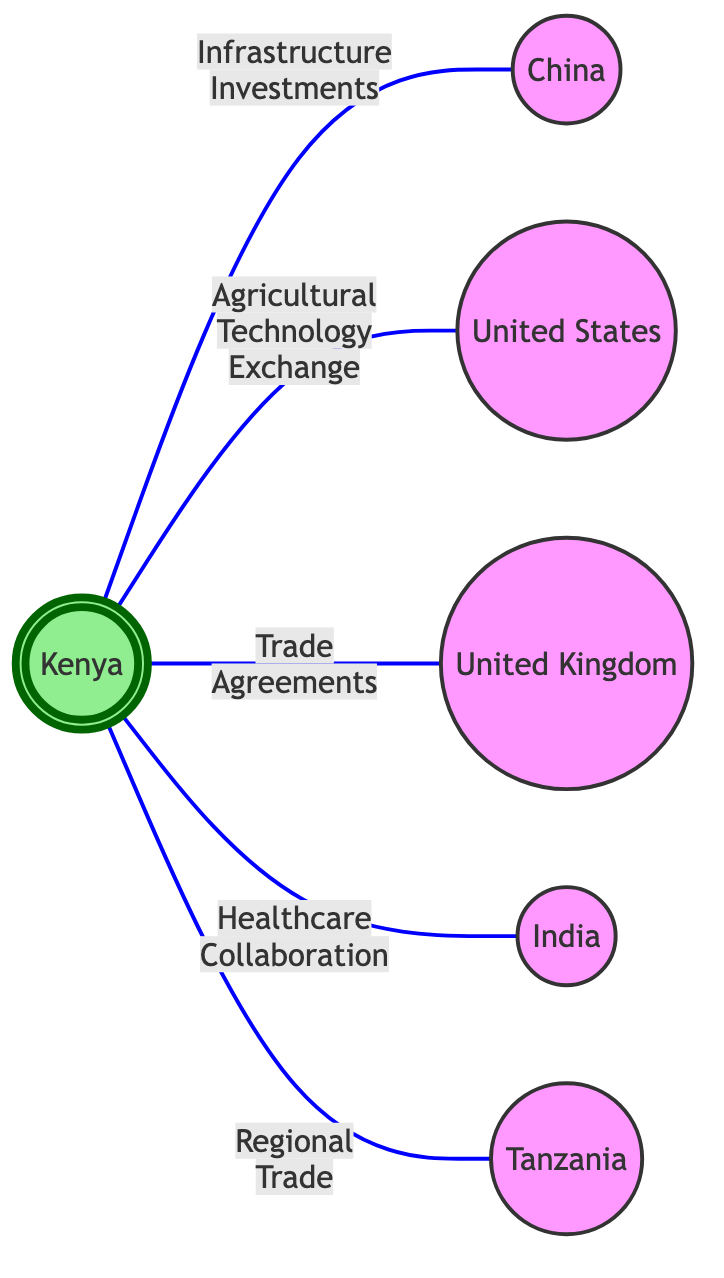What is the total number of countries represented in the diagram? The diagram includes six distinct nodes representing countries: Kenya, China, United States, United Kingdom, India, and Tanzania. Counting these gives a total of 6 countries.
Answer: 6 What type of collaboration exists between Kenya and China? The diagram shows an edge labeled "Infrastructure Investments" connecting Kenya and China, indicating the specific type of collaboration between these two countries.
Answer: Infrastructure Investments How many collaborations are shown between Kenya and other countries? There are five edges emerging from Kenya, each representing a different collaboration with the mentioned countries. Thus, there are 5 collaborations in total.
Answer: 5 Which country is connected to Kenya through healthcare collaboration? The diagram indicates an edge labeled "Healthcare Collaboration" connecting Kenya to India, identifying India as the country engaged in this type of collaboration with Kenya.
Answer: India Which two countries have a trade agreement with Kenya? The edges labeled "Trade Agreements" connect Kenya to the United Kingdom. Therefore, the United Kingdom is the only country shown in this diagram with a trade agreement with Kenya.
Answer: United Kingdom Which type of collaboration exists between Kenya and the United States? The diagram illustrates that there is an edge labeled "Agricultural Technology Exchange" between Kenya and the United States, clarifying the nature of their collaboration.
Answer: Agricultural Technology Exchange How many edges are connected to Kenya in the graph? Upon examining the diagram, there are five edges originating from Kenya, which connect to each of the other countries represented. This confirms that Kenya has 5 associated edges.
Answer: 5 Which country is connected to both Kenya and Tanzania? The relationships in the diagram indicate that Kenya has a direct connection to Tanzania through "Regional Trade"; however, it does not show any direct link for Tanzania with another country that connects to Kenya, making the answer none for this question.
Answer: None What type of collaboration is randomly established between Kenya and Tanzania? Reviewing the edges in the diagram reveals that there is an edge labeled "Regional Trade" connecting Kenya and Tanzania, specifying the form of collaboration between them.
Answer: Regional Trade 